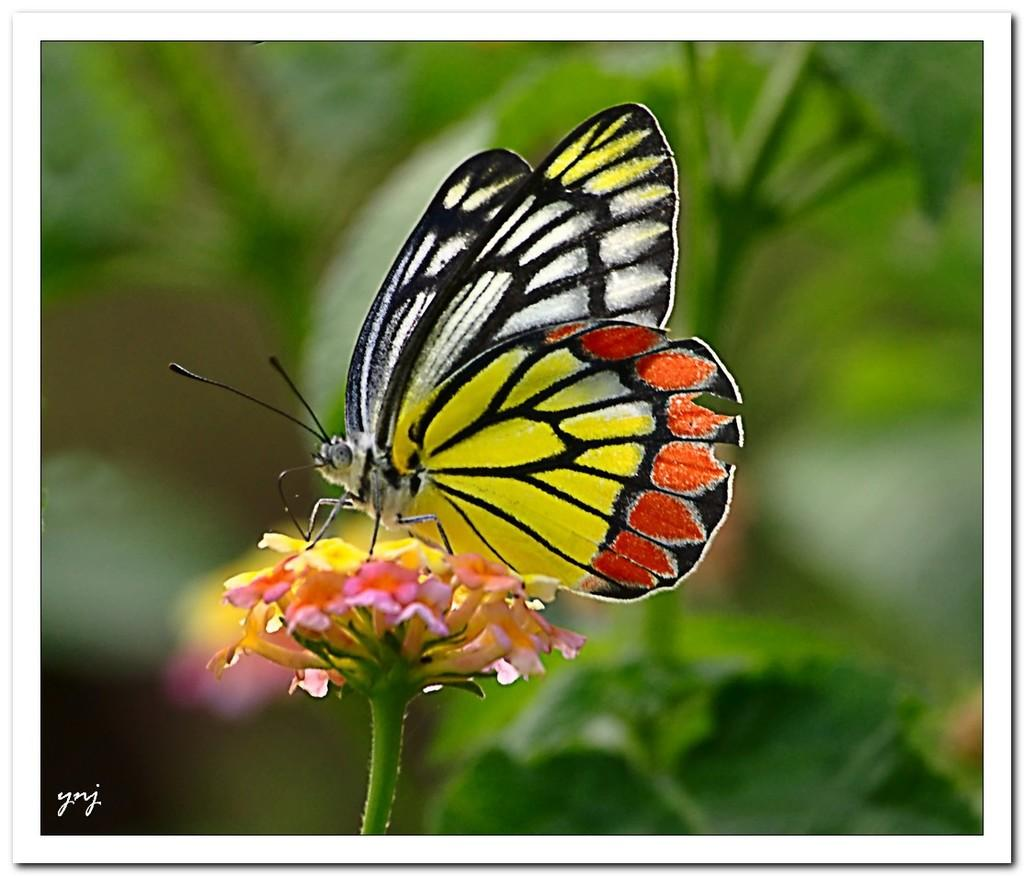What is the main subject of the image? There is a butterfly in the image. What is the butterfly doing in the image? The butterfly is sitting on a flower. Can you describe the background of the image? The background of the image is blurred. What book is the bear reading in the image? There is no bear or book present in the image; it features a butterfly sitting on a flower. 